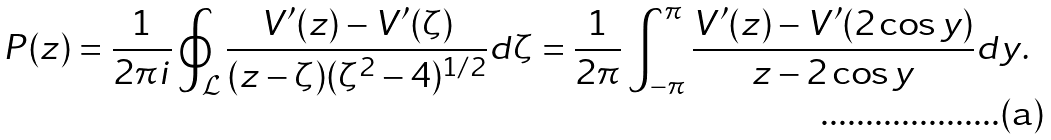<formula> <loc_0><loc_0><loc_500><loc_500>P ( z ) = \frac { 1 } { 2 \pi i } \oint _ { \mathcal { L } } \frac { V ^ { \prime } ( z ) - V ^ { \prime } ( \zeta ) } { ( z - \zeta ) ( \zeta ^ { 2 } - 4 ) ^ { 1 / 2 } } d \zeta = \frac { 1 } { 2 \pi } \int _ { - \pi } ^ { \pi } { \frac { V ^ { \prime } ( z ) - V ^ { \prime } ( 2 \cos y ) } { z - 2 \cos y } } d y .</formula> 